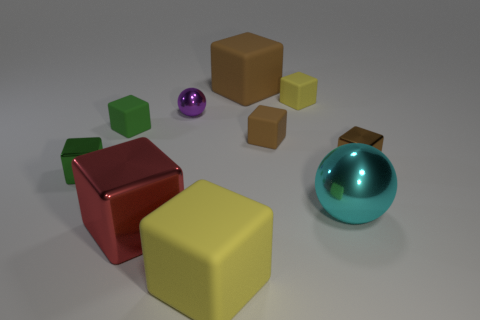How many tiny rubber cubes are on the right side of the sphere that is behind the small green object in front of the green matte thing?
Your answer should be compact. 2. How many rubber things are either small purple spheres or small brown blocks?
Give a very brief answer. 1. There is a yellow block to the right of the yellow rubber thing left of the big brown block; how big is it?
Give a very brief answer. Small. Do the large cube behind the purple metallic object and the metallic cube that is right of the small yellow rubber block have the same color?
Keep it short and to the point. Yes. There is a matte block that is both behind the purple metal ball and on the right side of the big brown rubber object; what is its color?
Offer a terse response. Yellow. Is the cyan sphere made of the same material as the purple object?
Make the answer very short. Yes. How many tiny objects are yellow metal balls or cyan objects?
Offer a very short reply. 0. There is a big block that is the same material as the purple thing; what is its color?
Give a very brief answer. Red. What is the color of the small block that is right of the tiny yellow rubber cube?
Make the answer very short. Brown. Is the number of tiny metal objects that are to the right of the large cyan thing less than the number of small brown objects that are on the right side of the brown metallic block?
Your response must be concise. No. 